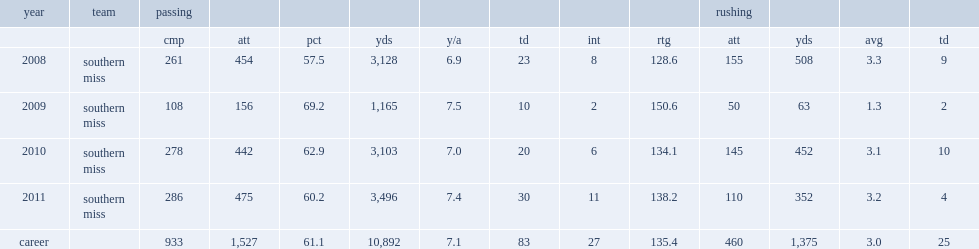How many rushing yards did davis get in 2011? 352.0. 